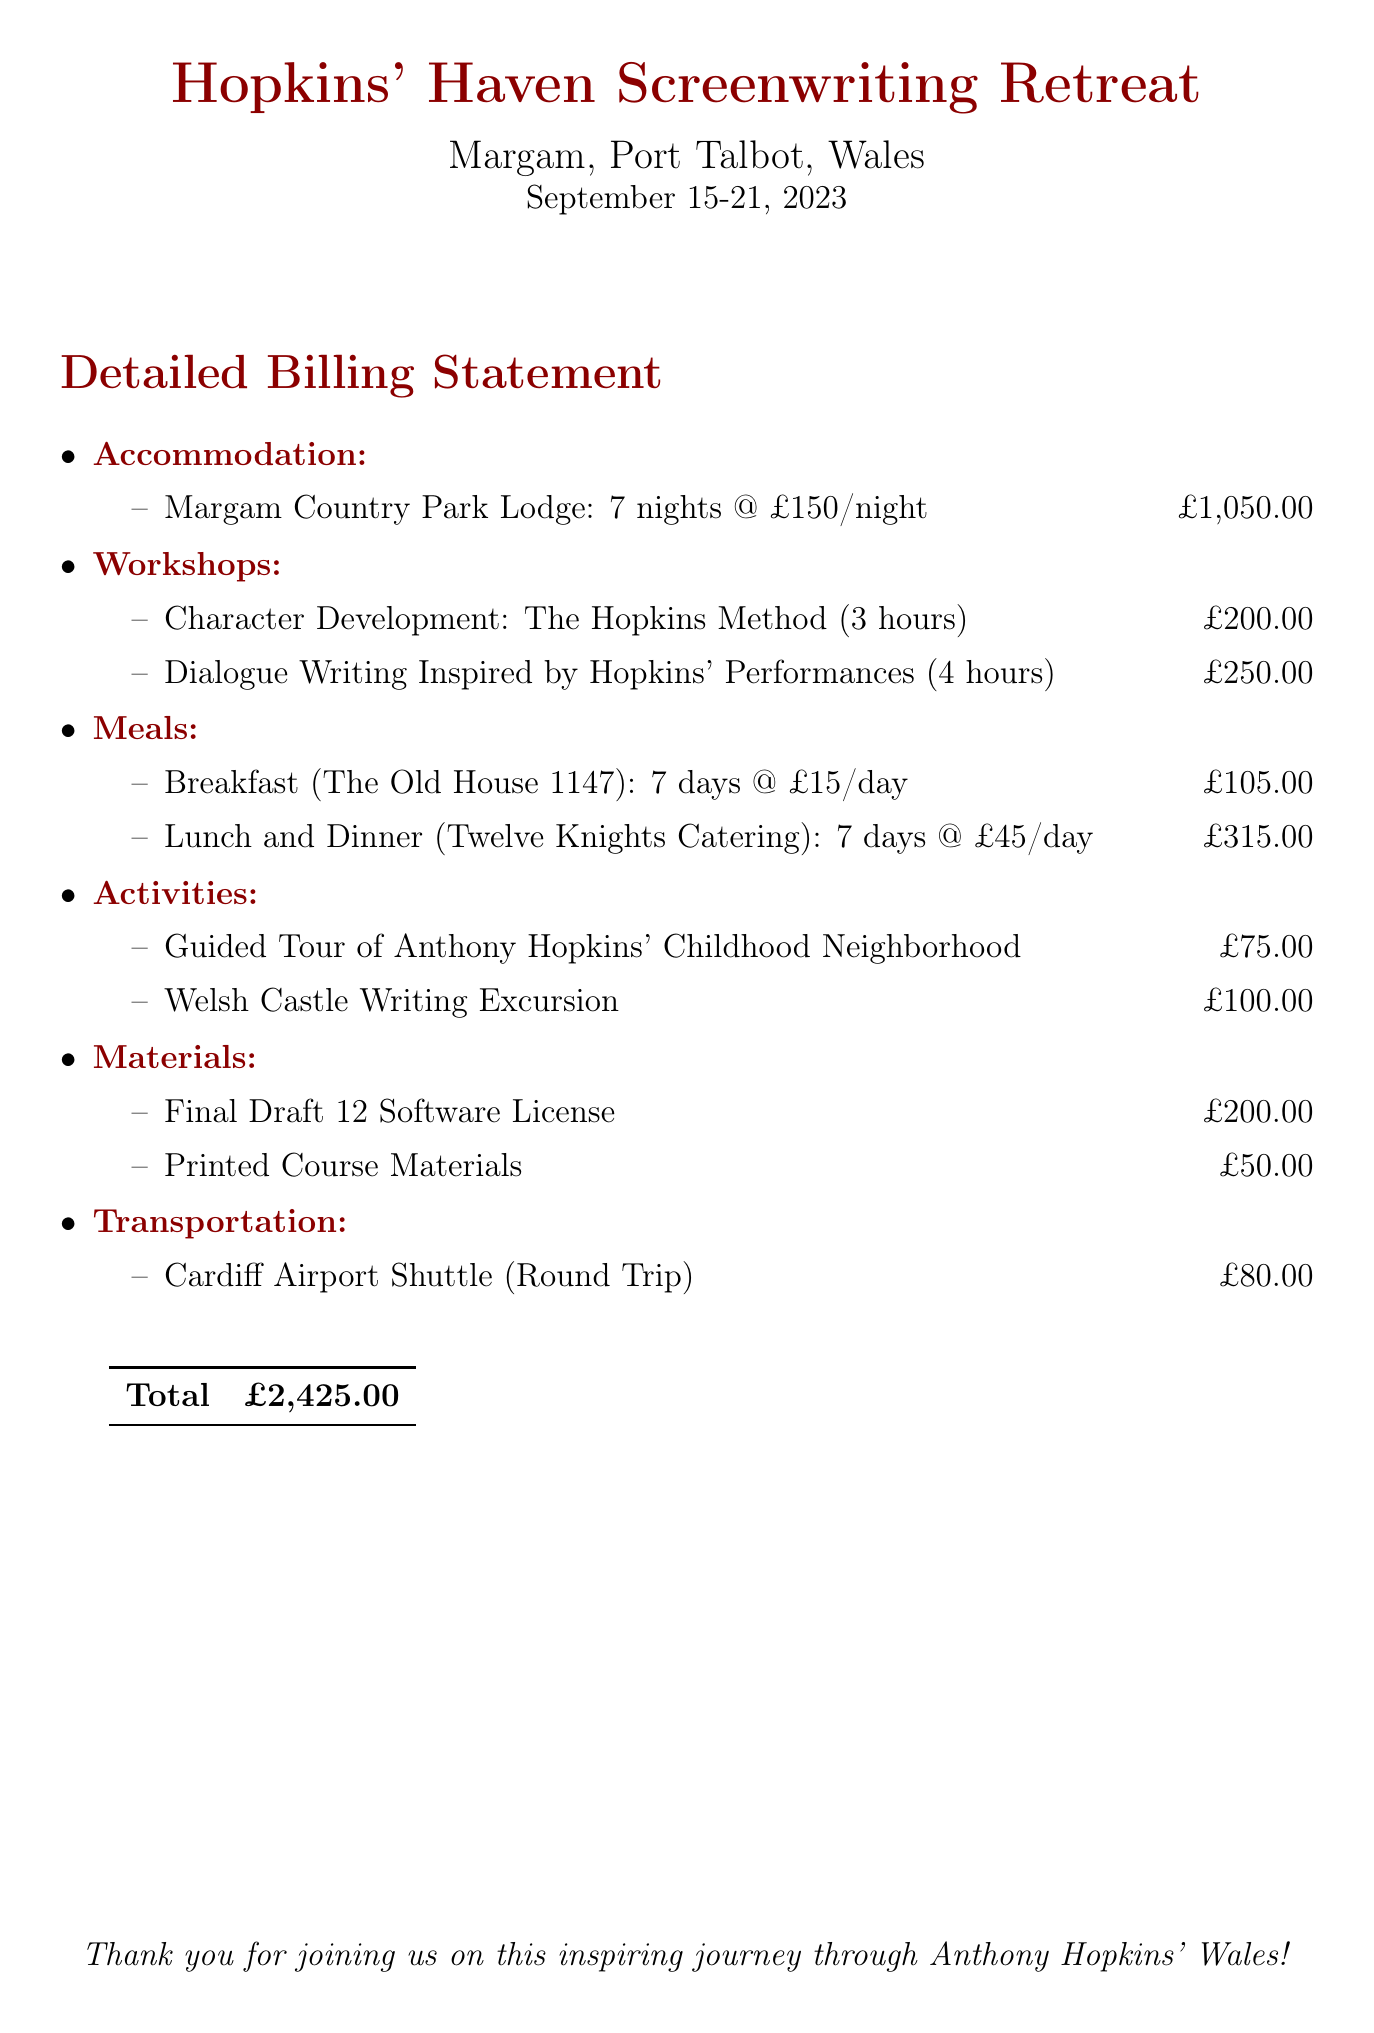What is the location of the retreat? The location of the retreat is stated at the top of the document.
Answer: Margam, Port Talbot, Wales What is the date range of the retreat? The date range is mentioned in the header section of the document.
Answer: September 15-21, 2023 How many nights of accommodation are included? The number of nights can be inferred from the accommodation section.
Answer: 7 nights What is the cost of the Character Development workshop? The cost is explicitly listed in the workshops section.
Answer: £200.00 What is the total amount charged for meals? The total for meals can be calculated by adding the daily charges for breakfast, lunch, and dinner over the specified days.
Answer: £420.00 What activity costs the most? The costs of activities are compared to find the highest price listed.
Answer: Welsh Castle Writing Excursion What is the charge for the Cardiff Airport Shuttle? The transportation cost is given in the document.
Answer: £80.00 What is the total bill? The total is presented at the bottom of the billing statement.
Answer: £2,425.00 Which software license is included in the materials? The materials section lists the included software.
Answer: Final Draft 12 Software License 